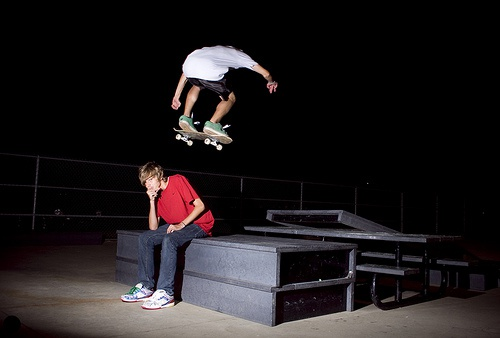Describe the objects in this image and their specific colors. I can see bench in black, darkgray, and gray tones, people in black, brown, and gray tones, people in black, lavender, tan, and darkgray tones, car in black and gray tones, and bench in black and gray tones in this image. 